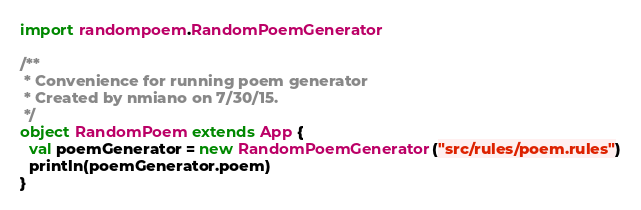Convert code to text. <code><loc_0><loc_0><loc_500><loc_500><_Scala_>import randompoem.RandomPoemGenerator

/**
 * Convenience for running poem generator
 * Created by nmiano on 7/30/15.
 */
object RandomPoem extends App {
  val poemGenerator = new RandomPoemGenerator("src/rules/poem.rules")
  println(poemGenerator.poem)
}
</code> 